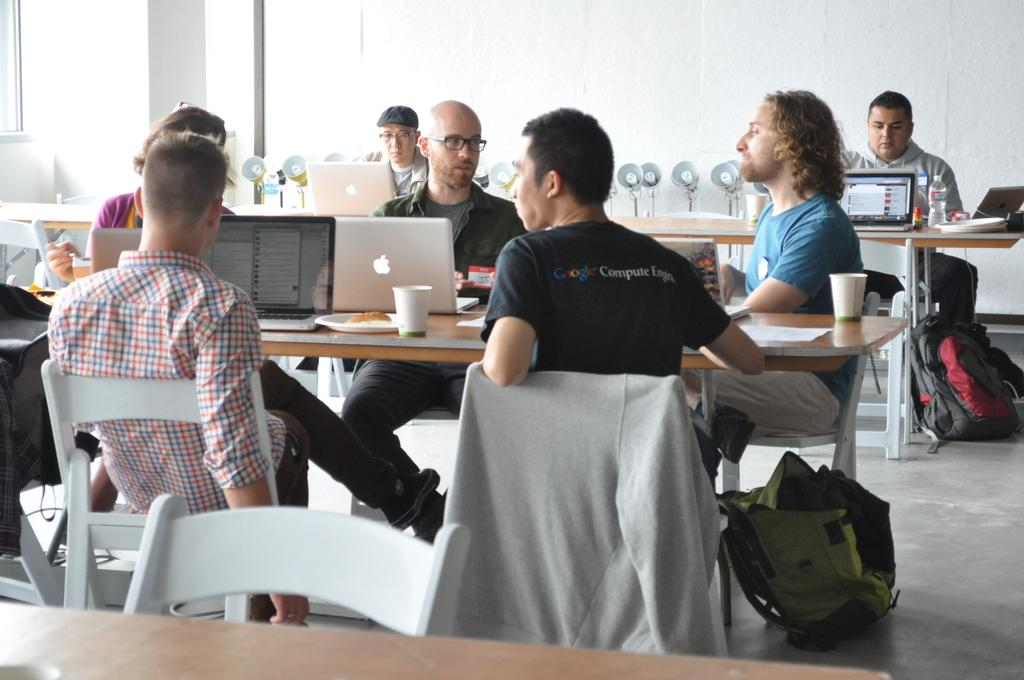<image>
Render a clear and concise summary of the photo. Man wearing a black Google shirt in a meeting with others. 